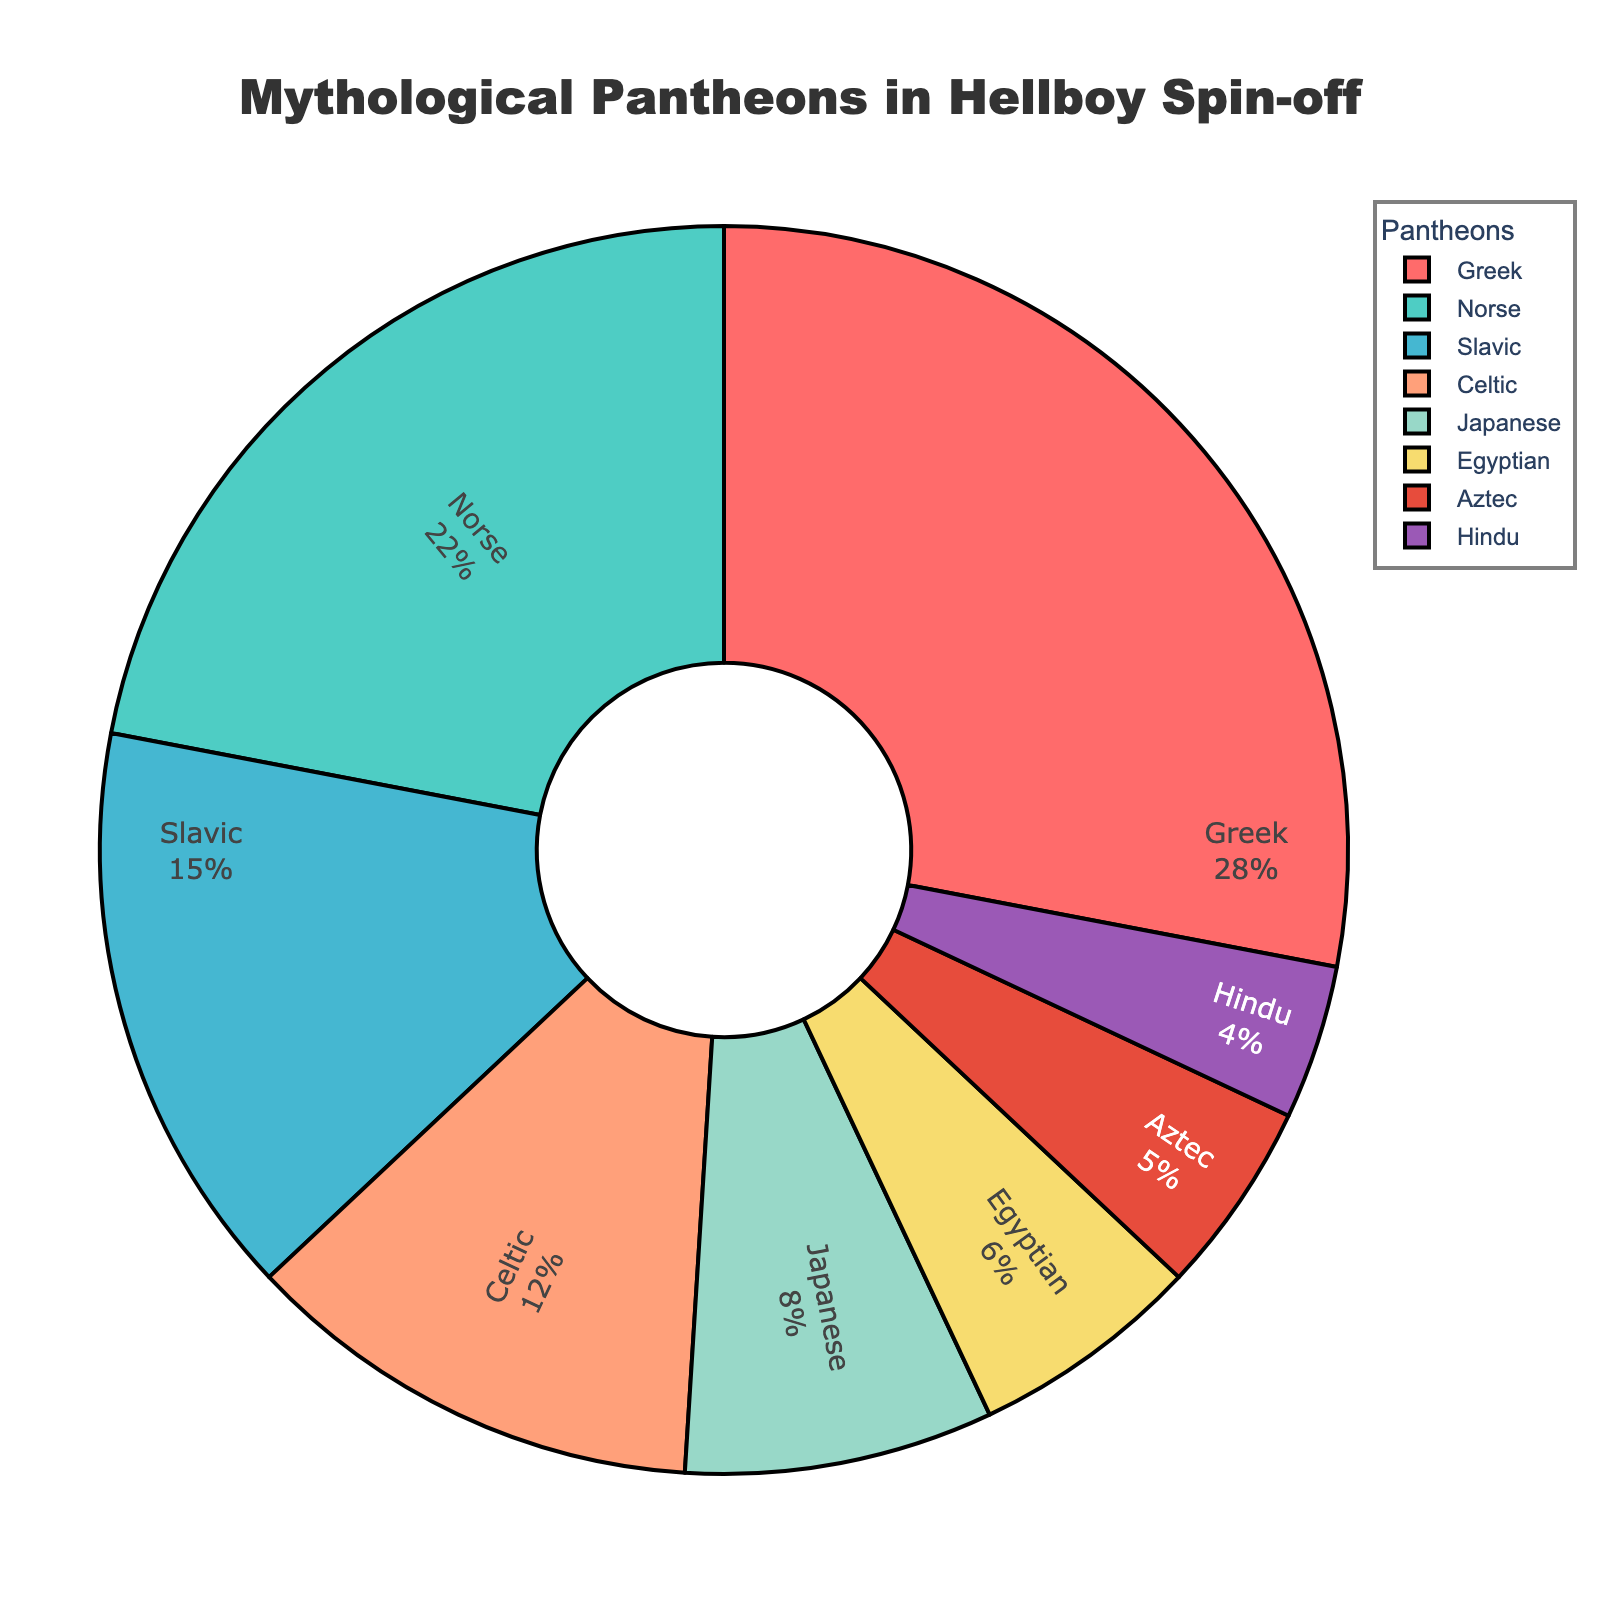Which pantheon has the highest representation in the Hellboy spin-off? The Greek pantheon has the highest representation with 28%. This is evident from both the percentage and the largeness of the corresponding section of the pie chart.
Answer: Greek Which pantheon represents less than 10% but more than 5% of the total? Both the Japanese and Egyptian pantheons fit this description. The Japanese pantheon represents 8%, and the Egyptian pantheon represents 6%.
Answer: Japanese and Egyptian How much larger is the Greek pantheon compared to the Slavic pantheon? The Greek pantheon is represented by 28%, whereas the Slavic pantheon is represented by 15%. The difference is 28% - 15% = 13%.
Answer: 13% What is the combined representation of Celtic and Aztec pantheons in the series? The Celtic pantheon represents 12% and the Aztec pantheon represents 5%. Summing these up gives 12% + 5% = 17%.
Answer: 17% Which two pantheons have the closest percentage representation? The Japanese and Egyptian pantheons have percentages of 8% and 6%, respectively. The difference is 2%, which is smaller than the differences between other pairs.
Answer: Japanese and Egyptian If you were to combine the Norse and Hindu pantheons, what would their total representation be? The Norse pantheon represents 22% and the Hindu pantheon represents 4%. Together, their representation would be 22% + 4% = 26%.
Answer: 26% Which pantheon has the smallest representation, and what is its percentage? The Hindu pantheon has the smallest representation with 4%. This is the smallest percentage represented in the pie chart.
Answer: Hindu, 4% What proportion of the total is represented by non-European pantheons (Japanese, Egyptian, Aztec, Hindu)? The Japanese pantheon is 8%, the Egyptian is 6%, the Aztec is 5%, and the Hindu is 4%. Combined, these non-European pantheons represent 8% + 6% + 5% + 4% = 23%.
Answer: 23% Which color corresponds to the Celtic pantheon in the pie chart? The Celtic pantheon is represented with a peach/salmon color. This can be identified visually from the pie chart, where the section labeled Celtic is shaded in this color.
Answer: Peach/Salmon Is the Norse pantheon’s representation greater than the combined representation of the Aztec and Hindu pantheons? The Norse pantheon represents 22%. The combined representation for the Aztec and Hindu pantheons is 5% + 4% = 9%. Since 22% > 9%, the Norse representation is indeed greater.
Answer: Yes, greater 